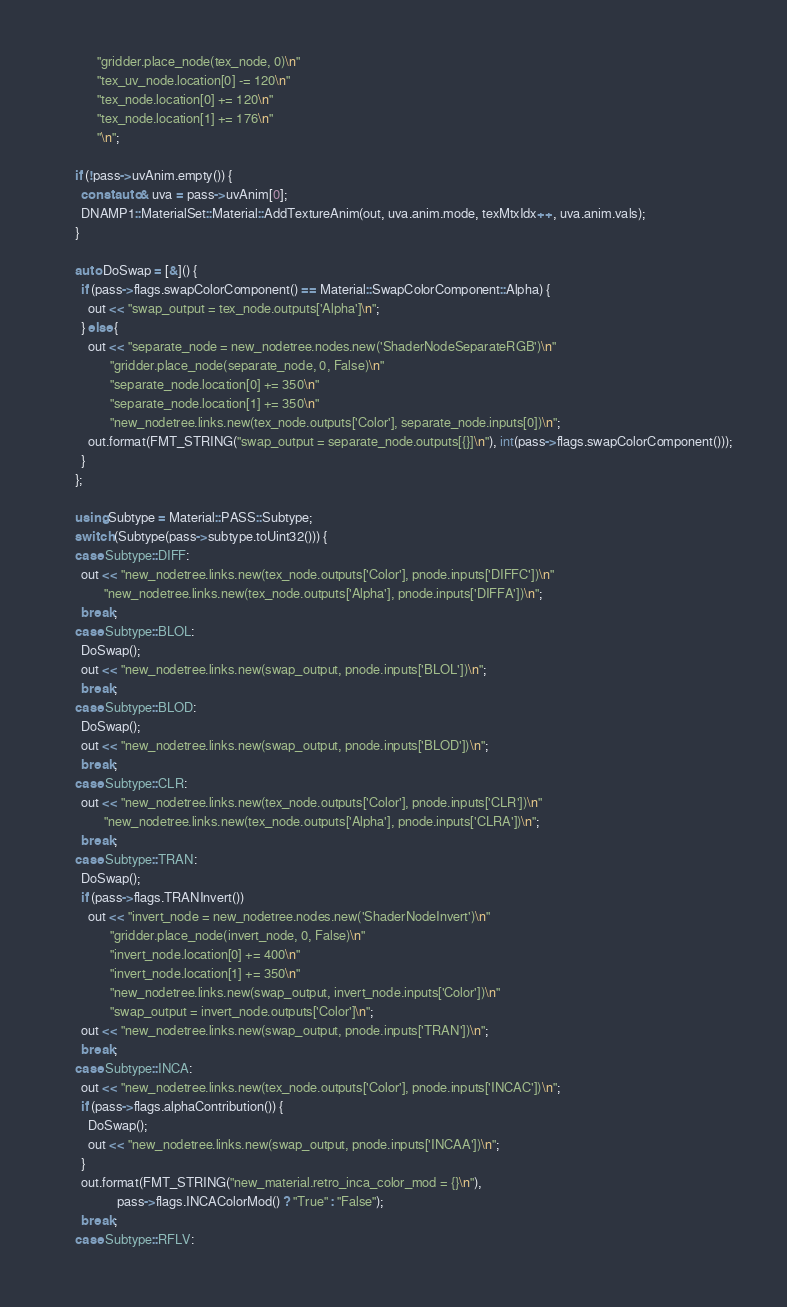<code> <loc_0><loc_0><loc_500><loc_500><_C++_>             "gridder.place_node(tex_node, 0)\n"
             "tex_uv_node.location[0] -= 120\n"
             "tex_node.location[0] += 120\n"
             "tex_node.location[1] += 176\n"
             "\n";

      if (!pass->uvAnim.empty()) {
        const auto& uva = pass->uvAnim[0];
        DNAMP1::MaterialSet::Material::AddTextureAnim(out, uva.anim.mode, texMtxIdx++, uva.anim.vals);
      }

      auto DoSwap = [&]() {
        if (pass->flags.swapColorComponent() == Material::SwapColorComponent::Alpha) {
          out << "swap_output = tex_node.outputs['Alpha']\n";
        } else {
          out << "separate_node = new_nodetree.nodes.new('ShaderNodeSeparateRGB')\n"
                 "gridder.place_node(separate_node, 0, False)\n"
                 "separate_node.location[0] += 350\n"
                 "separate_node.location[1] += 350\n"
                 "new_nodetree.links.new(tex_node.outputs['Color'], separate_node.inputs[0])\n";
          out.format(FMT_STRING("swap_output = separate_node.outputs[{}]\n"), int(pass->flags.swapColorComponent()));
        }
      };

      using Subtype = Material::PASS::Subtype;
      switch (Subtype(pass->subtype.toUint32())) {
      case Subtype::DIFF:
        out << "new_nodetree.links.new(tex_node.outputs['Color'], pnode.inputs['DIFFC'])\n"
               "new_nodetree.links.new(tex_node.outputs['Alpha'], pnode.inputs['DIFFA'])\n";
        break;
      case Subtype::BLOL:
        DoSwap();
        out << "new_nodetree.links.new(swap_output, pnode.inputs['BLOL'])\n";
        break;
      case Subtype::BLOD:
        DoSwap();
        out << "new_nodetree.links.new(swap_output, pnode.inputs['BLOD'])\n";
        break;
      case Subtype::CLR:
        out << "new_nodetree.links.new(tex_node.outputs['Color'], pnode.inputs['CLR'])\n"
               "new_nodetree.links.new(tex_node.outputs['Alpha'], pnode.inputs['CLRA'])\n";
        break;
      case Subtype::TRAN:
        DoSwap();
        if (pass->flags.TRANInvert())
          out << "invert_node = new_nodetree.nodes.new('ShaderNodeInvert')\n"
                 "gridder.place_node(invert_node, 0, False)\n"
                 "invert_node.location[0] += 400\n"
                 "invert_node.location[1] += 350\n"
                 "new_nodetree.links.new(swap_output, invert_node.inputs['Color'])\n"
                 "swap_output = invert_node.outputs['Color']\n";
        out << "new_nodetree.links.new(swap_output, pnode.inputs['TRAN'])\n";
        break;
      case Subtype::INCA:
        out << "new_nodetree.links.new(tex_node.outputs['Color'], pnode.inputs['INCAC'])\n";
        if (pass->flags.alphaContribution()) {
          DoSwap();
          out << "new_nodetree.links.new(swap_output, pnode.inputs['INCAA'])\n";
        }
        out.format(FMT_STRING("new_material.retro_inca_color_mod = {}\n"),
                   pass->flags.INCAColorMod() ? "True" : "False");
        break;
      case Subtype::RFLV:</code> 